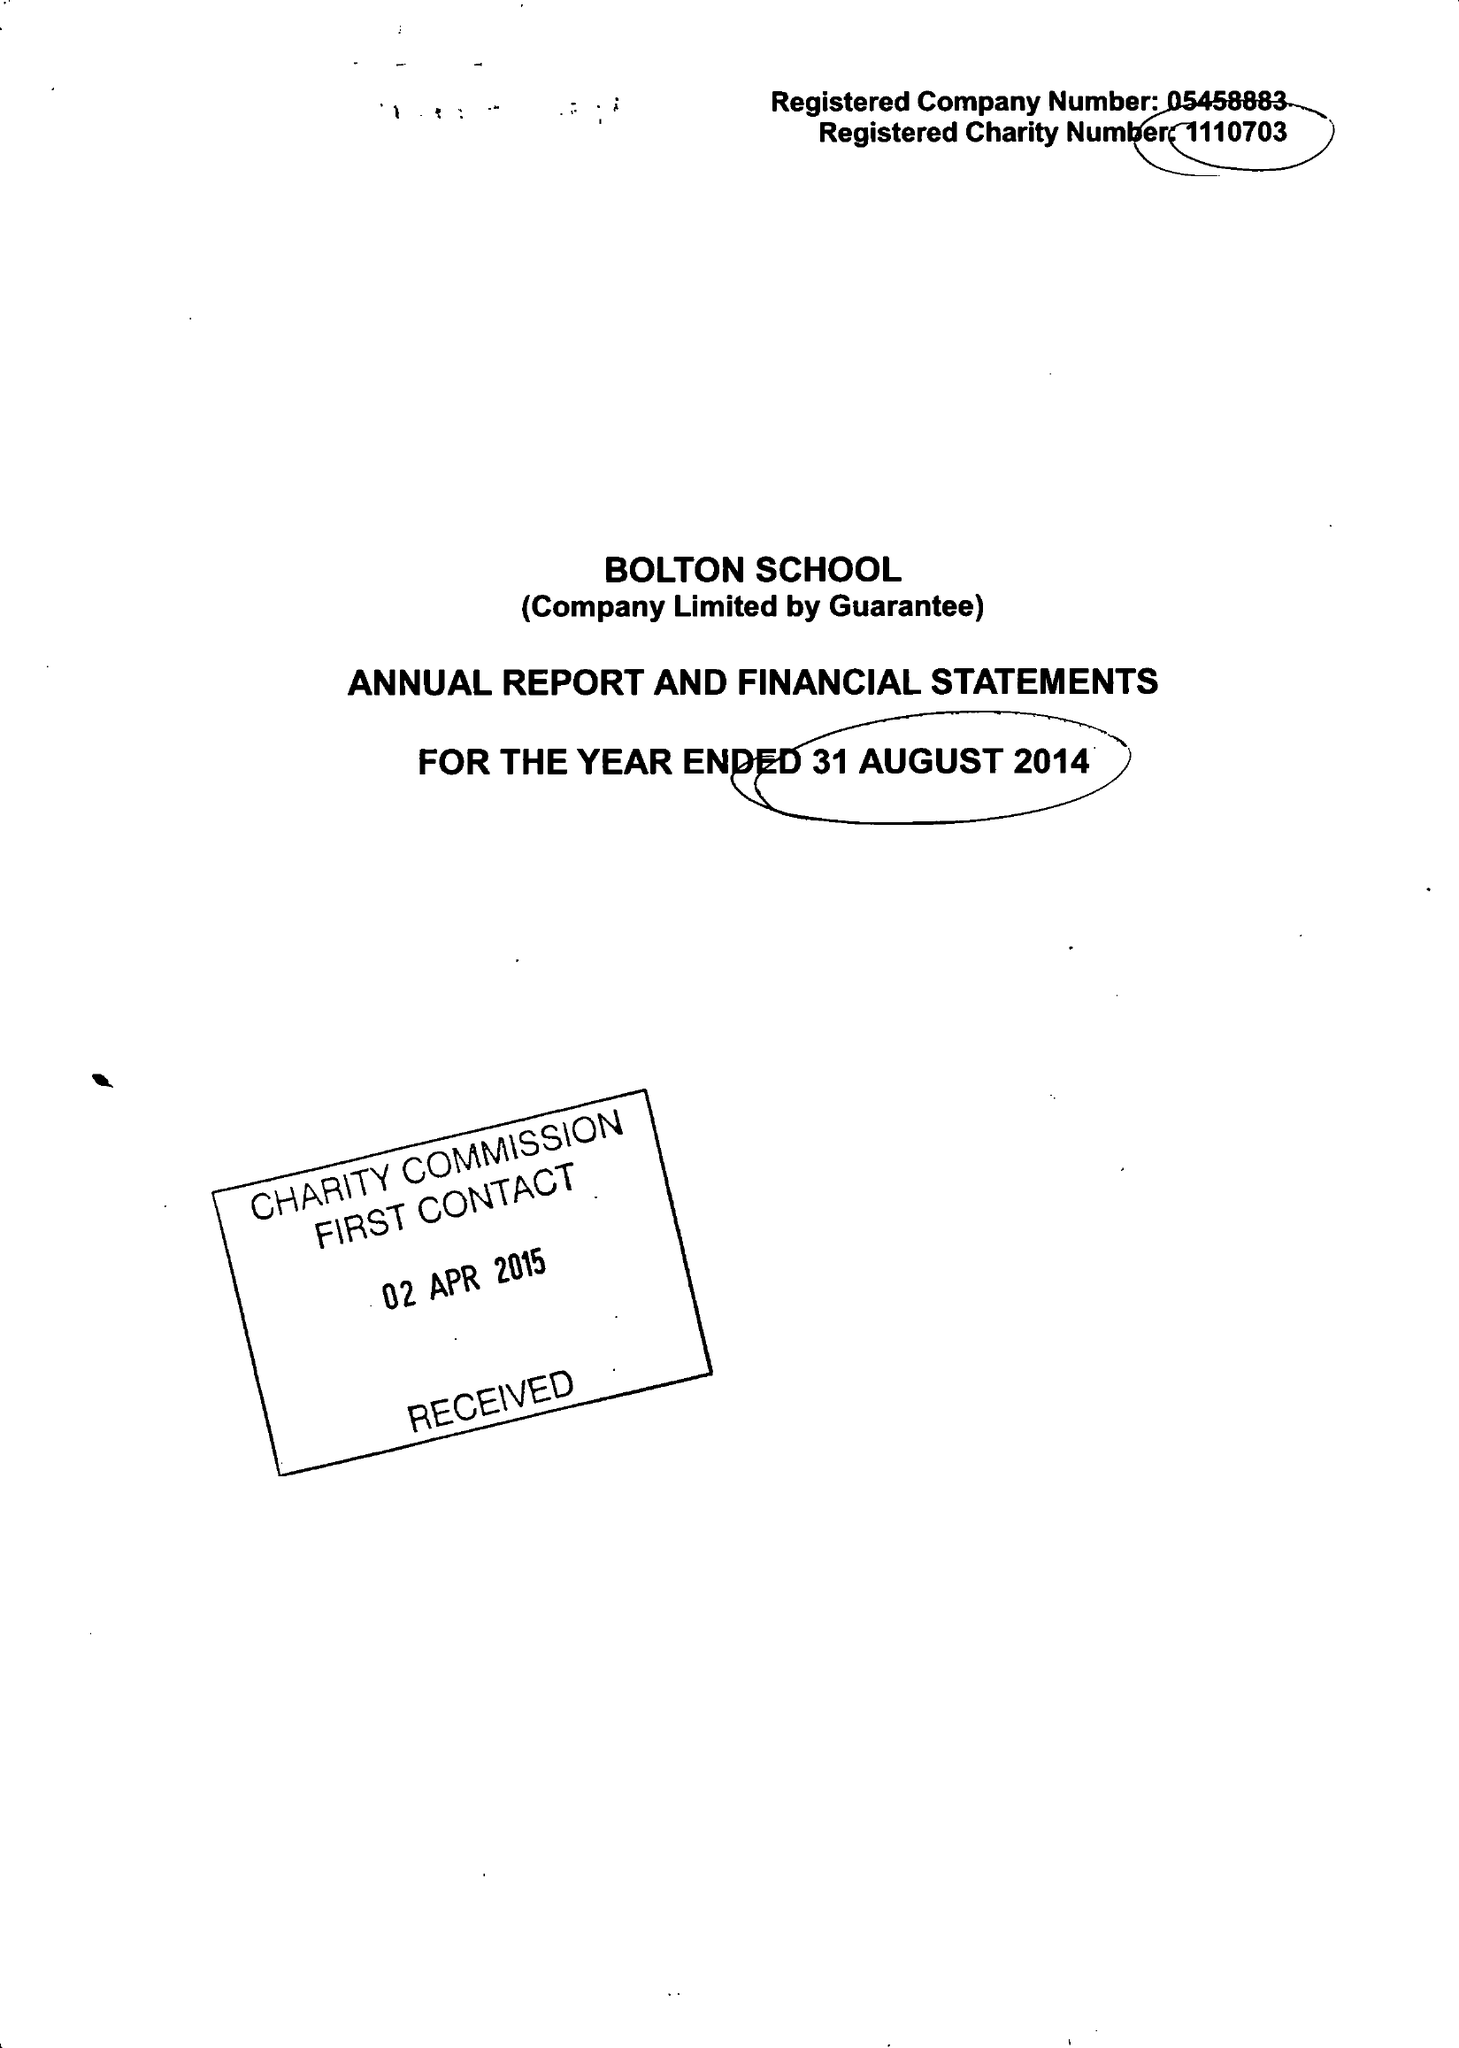What is the value for the spending_annually_in_british_pounds?
Answer the question using a single word or phrase. 25509000.00 